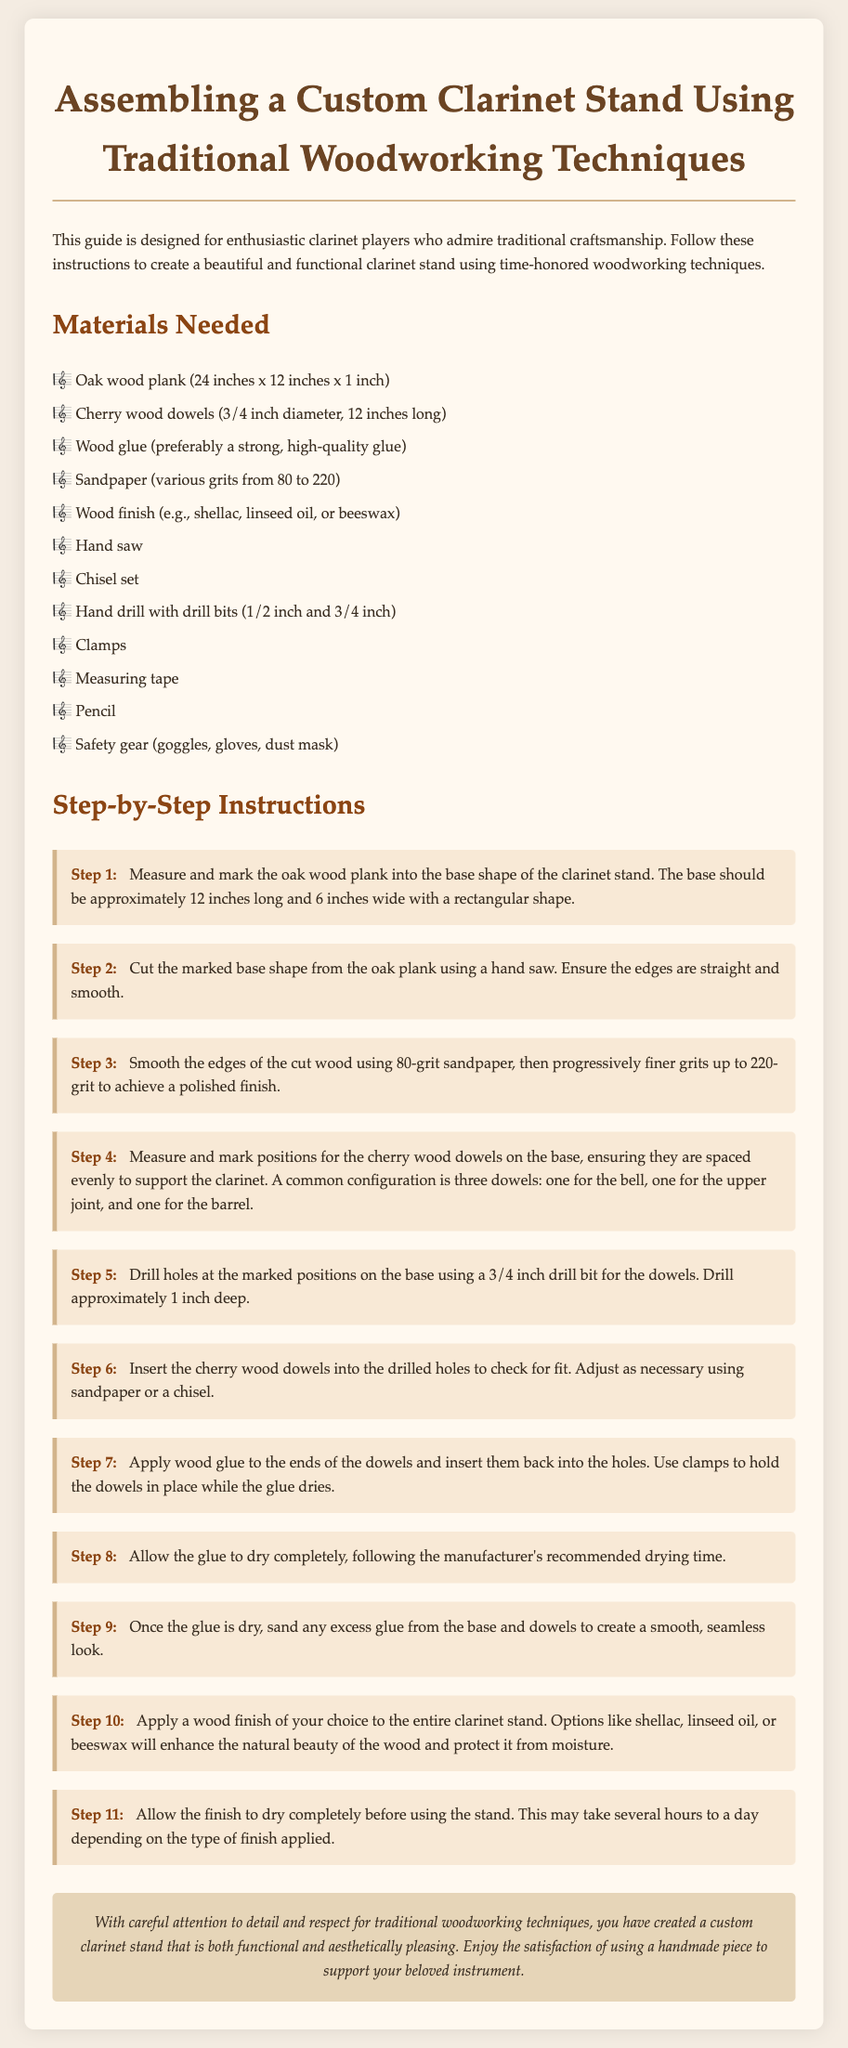What materials are needed for the stand? The materials are listed under "Materials Needed" in the document, which includes oak wood, cherry wood dowels, wood glue, sandpaper, and others.
Answer: Oak wood plank, cherry wood dowels, wood glue, sandpaper, wood finish, hand saw, chisel set, hand drill, clamps, measuring tape, pencil, safety gear What is the dimension of the oak wood plank? The document specifies the dimensions of the oak wood plank as 24 inches x 12 inches x 1 inch.
Answer: 24 inches x 12 inches x 1 inch How many dowels are used in the stand configuration? The instructions mention a common configuration of three dowels to support the clarinet.
Answer: Three dowels What grit sandpaper do you start with? The document states that you begin smoothing the edges with 80-grit sandpaper.
Answer: 80-grit What is the purpose of applying wood glue to the dowels? The wood glue is applied to secure the dowels in place after insertion into the holes.
Answer: To hold the dowels in place How long should you allow the finish to dry? The document advises that drying may take several hours to a day, depending on the finish type.
Answer: Several hours to a day Which finish options are suggested for the clarinet stand? The instructions list options such as shellac, linseed oil, or beeswax for finishing the stand.
Answer: Shellac, linseed oil, beeswax What should you use to check the fit of the dowels? The document recommends inserting the cherry wood dowels into the drilled holes to check for fit.
Answer: Insert the dowels What is the final step mentioned in the assembly process? The last step involves allowing the finish to dry completely before using the stand.
Answer: Allow the finish to dry completely 